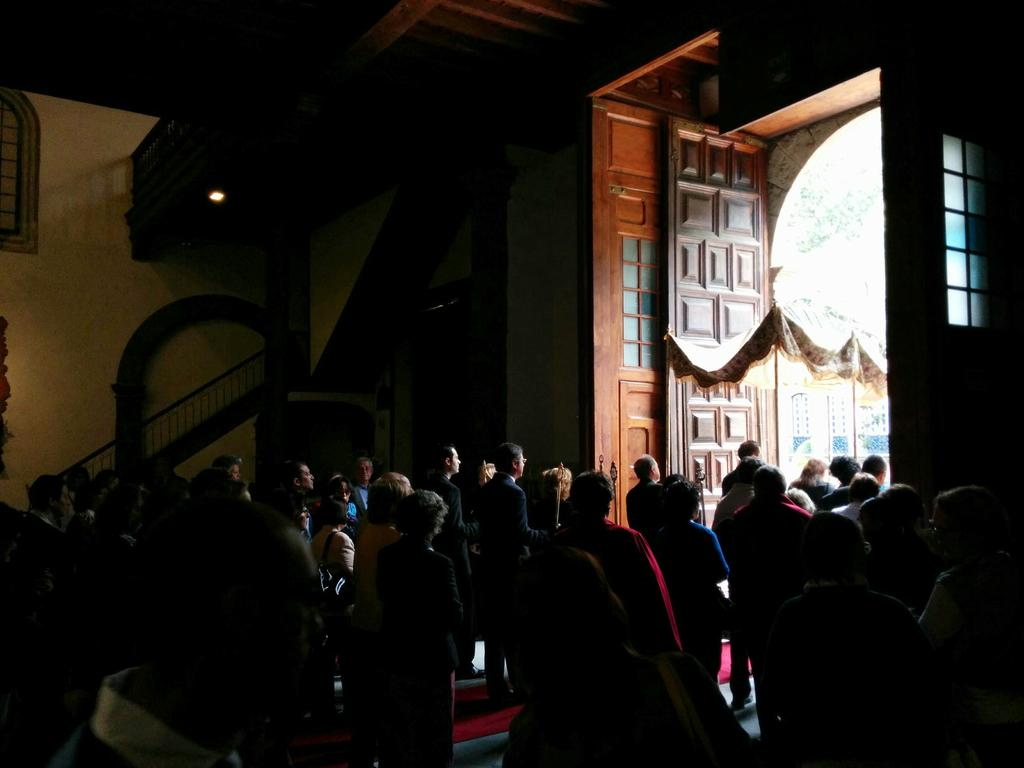Who or what can be seen in the image? There are people in the image. What architectural feature is present in the image? There is a staircase in the image. What type of door is visible in the image? There is a tall door in the image. What level of difficulty does the fiction book have for beginners in the image? There is no fiction book present in the image, so it is not possible to determine its level of difficulty for beginners. 